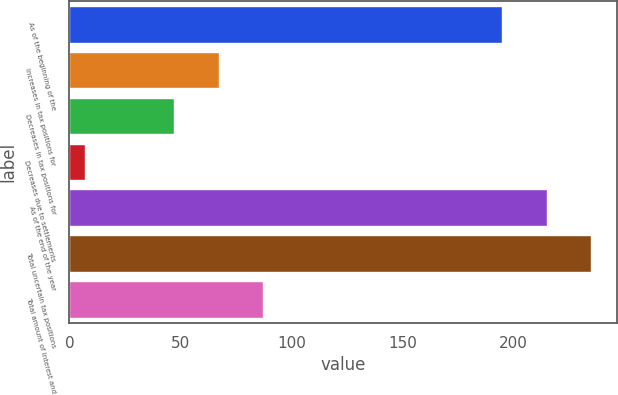Convert chart to OTSL. <chart><loc_0><loc_0><loc_500><loc_500><bar_chart><fcel>As of the beginning of the<fcel>Increases in tax positions for<fcel>Decreases in tax positions for<fcel>Decreases due to settlements<fcel>As of the end of the year<fcel>Total uncertain tax positions<fcel>Total amount of interest and<nl><fcel>195<fcel>67.3<fcel>47.2<fcel>7<fcel>215.1<fcel>235.2<fcel>87.4<nl></chart> 